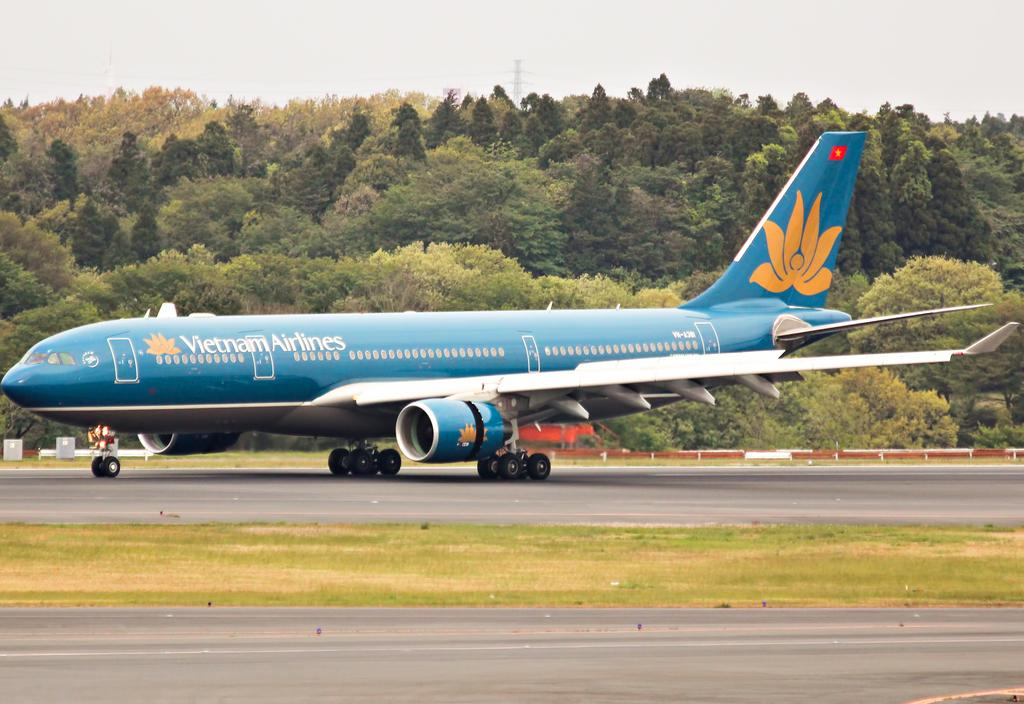<image>
Summarize the visual content of the image. A blue Vietnam Airlines plane that is on the runway. 